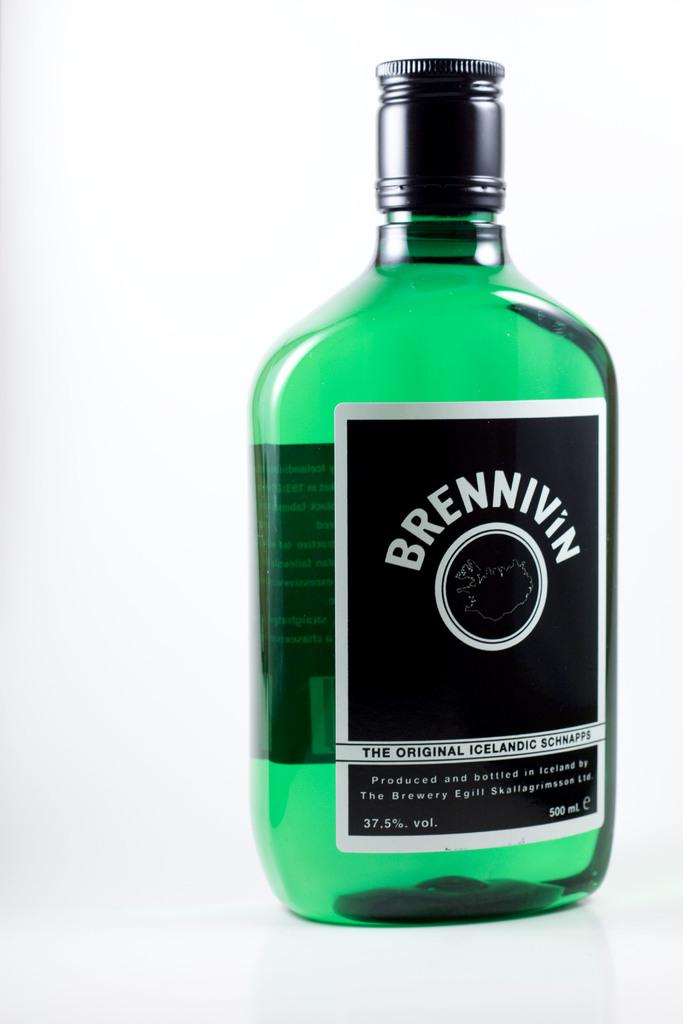<image>
Write a terse but informative summary of the picture. A bottle of Brennivin Icelandic Schnapps is green. 